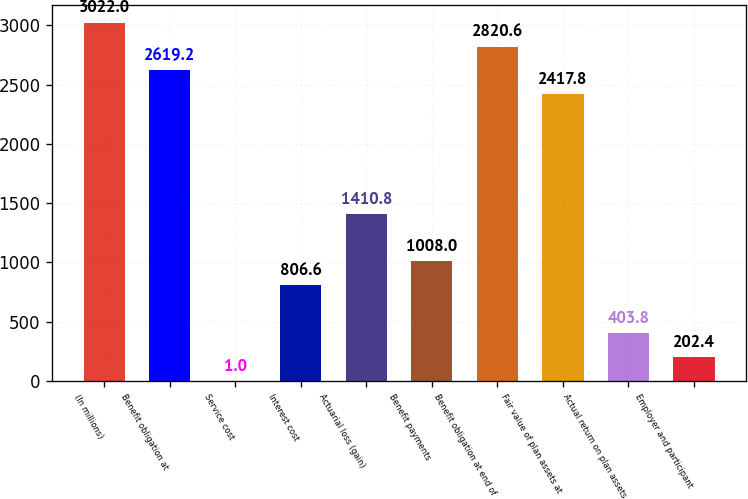Convert chart. <chart><loc_0><loc_0><loc_500><loc_500><bar_chart><fcel>(In millions)<fcel>Benefit obligation at<fcel>Service cost<fcel>Interest cost<fcel>Actuarial loss (gain)<fcel>Benefit payments<fcel>Benefit obligation at end of<fcel>Fair value of plan assets at<fcel>Actual return on plan assets<fcel>Employer and participant<nl><fcel>3022<fcel>2619.2<fcel>1<fcel>806.6<fcel>1410.8<fcel>1008<fcel>2820.6<fcel>2417.8<fcel>403.8<fcel>202.4<nl></chart> 